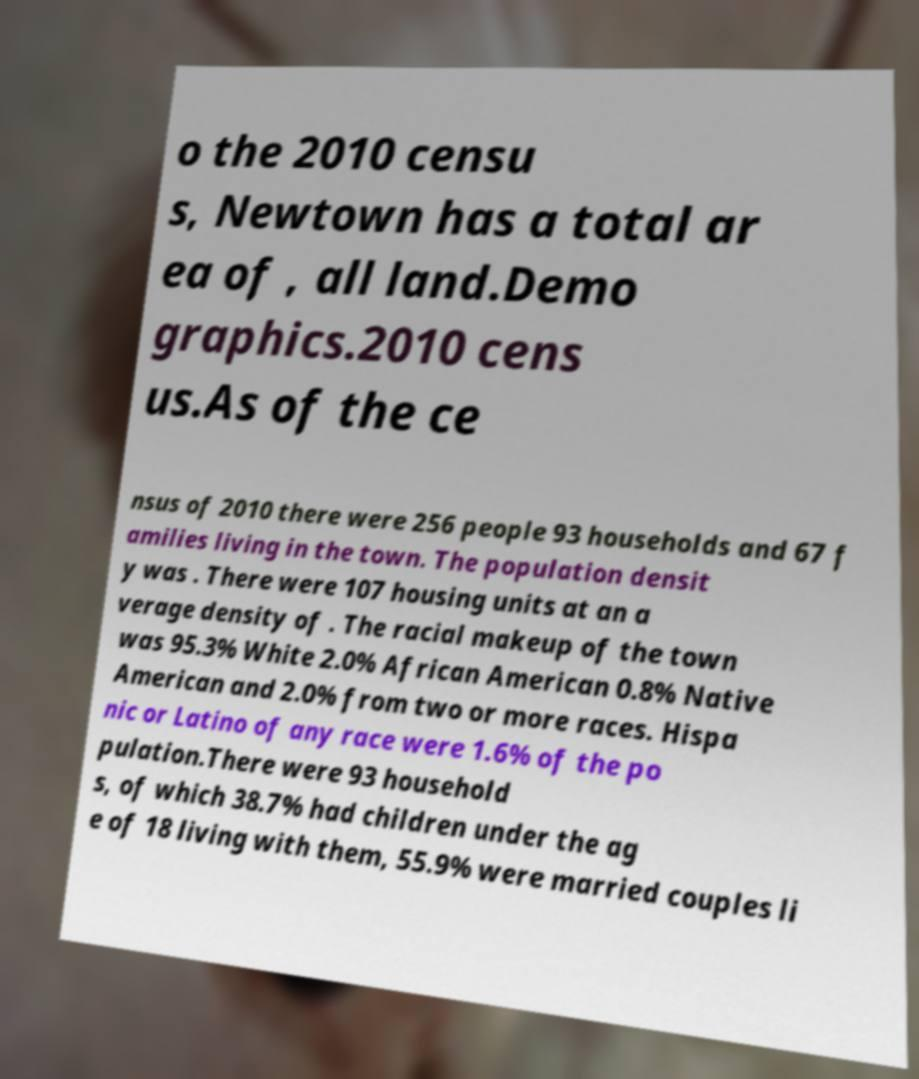Please read and relay the text visible in this image. What does it say? o the 2010 censu s, Newtown has a total ar ea of , all land.Demo graphics.2010 cens us.As of the ce nsus of 2010 there were 256 people 93 households and 67 f amilies living in the town. The population densit y was . There were 107 housing units at an a verage density of . The racial makeup of the town was 95.3% White 2.0% African American 0.8% Native American and 2.0% from two or more races. Hispa nic or Latino of any race were 1.6% of the po pulation.There were 93 household s, of which 38.7% had children under the ag e of 18 living with them, 55.9% were married couples li 